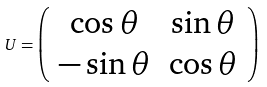<formula> <loc_0><loc_0><loc_500><loc_500>U = \left ( \begin{array} { c c } \cos \theta & \sin \theta \\ - \sin \theta & \cos \theta \end{array} \right ) \,</formula> 